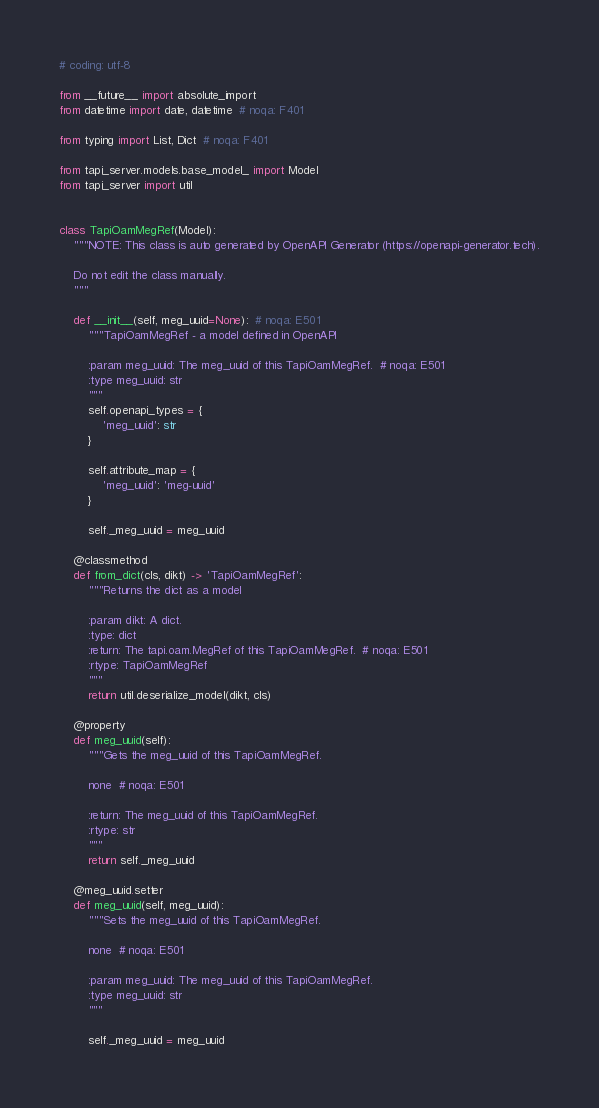Convert code to text. <code><loc_0><loc_0><loc_500><loc_500><_Python_># coding: utf-8

from __future__ import absolute_import
from datetime import date, datetime  # noqa: F401

from typing import List, Dict  # noqa: F401

from tapi_server.models.base_model_ import Model
from tapi_server import util


class TapiOamMegRef(Model):
    """NOTE: This class is auto generated by OpenAPI Generator (https://openapi-generator.tech).

    Do not edit the class manually.
    """

    def __init__(self, meg_uuid=None):  # noqa: E501
        """TapiOamMegRef - a model defined in OpenAPI

        :param meg_uuid: The meg_uuid of this TapiOamMegRef.  # noqa: E501
        :type meg_uuid: str
        """
        self.openapi_types = {
            'meg_uuid': str
        }

        self.attribute_map = {
            'meg_uuid': 'meg-uuid'
        }

        self._meg_uuid = meg_uuid

    @classmethod
    def from_dict(cls, dikt) -> 'TapiOamMegRef':
        """Returns the dict as a model

        :param dikt: A dict.
        :type: dict
        :return: The tapi.oam.MegRef of this TapiOamMegRef.  # noqa: E501
        :rtype: TapiOamMegRef
        """
        return util.deserialize_model(dikt, cls)

    @property
    def meg_uuid(self):
        """Gets the meg_uuid of this TapiOamMegRef.

        none  # noqa: E501

        :return: The meg_uuid of this TapiOamMegRef.
        :rtype: str
        """
        return self._meg_uuid

    @meg_uuid.setter
    def meg_uuid(self, meg_uuid):
        """Sets the meg_uuid of this TapiOamMegRef.

        none  # noqa: E501

        :param meg_uuid: The meg_uuid of this TapiOamMegRef.
        :type meg_uuid: str
        """

        self._meg_uuid = meg_uuid
</code> 